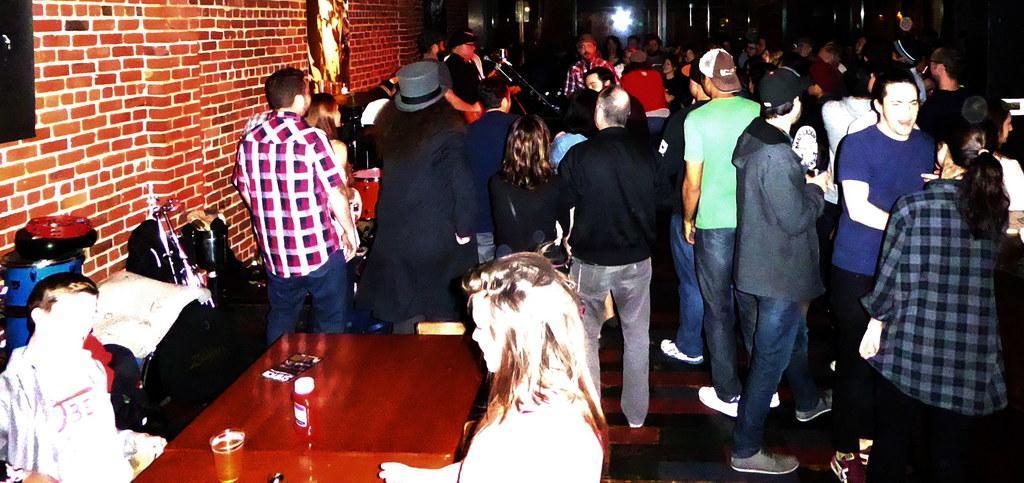In one or two sentences, can you explain what this image depicts? This picture describe about the big party hall. In front we can see group of a boys and girls standing and discussing something. In front we can see wooden table on which girl and boy is sitting. Behind we can see big red color brick wall. 